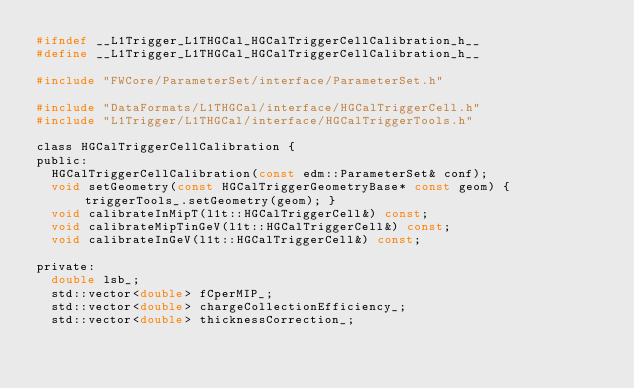Convert code to text. <code><loc_0><loc_0><loc_500><loc_500><_C_>#ifndef __L1Trigger_L1THGCal_HGCalTriggerCellCalibration_h__
#define __L1Trigger_L1THGCal_HGCalTriggerCellCalibration_h__

#include "FWCore/ParameterSet/interface/ParameterSet.h"

#include "DataFormats/L1THGCal/interface/HGCalTriggerCell.h"
#include "L1Trigger/L1THGCal/interface/HGCalTriggerTools.h"

class HGCalTriggerCellCalibration {
public:
  HGCalTriggerCellCalibration(const edm::ParameterSet& conf);
  void setGeometry(const HGCalTriggerGeometryBase* const geom) { triggerTools_.setGeometry(geom); }
  void calibrateInMipT(l1t::HGCalTriggerCell&) const;
  void calibrateMipTinGeV(l1t::HGCalTriggerCell&) const;
  void calibrateInGeV(l1t::HGCalTriggerCell&) const;

private:
  double lsb_;
  std::vector<double> fCperMIP_;
  std::vector<double> chargeCollectionEfficiency_;
  std::vector<double> thicknessCorrection_;</code> 